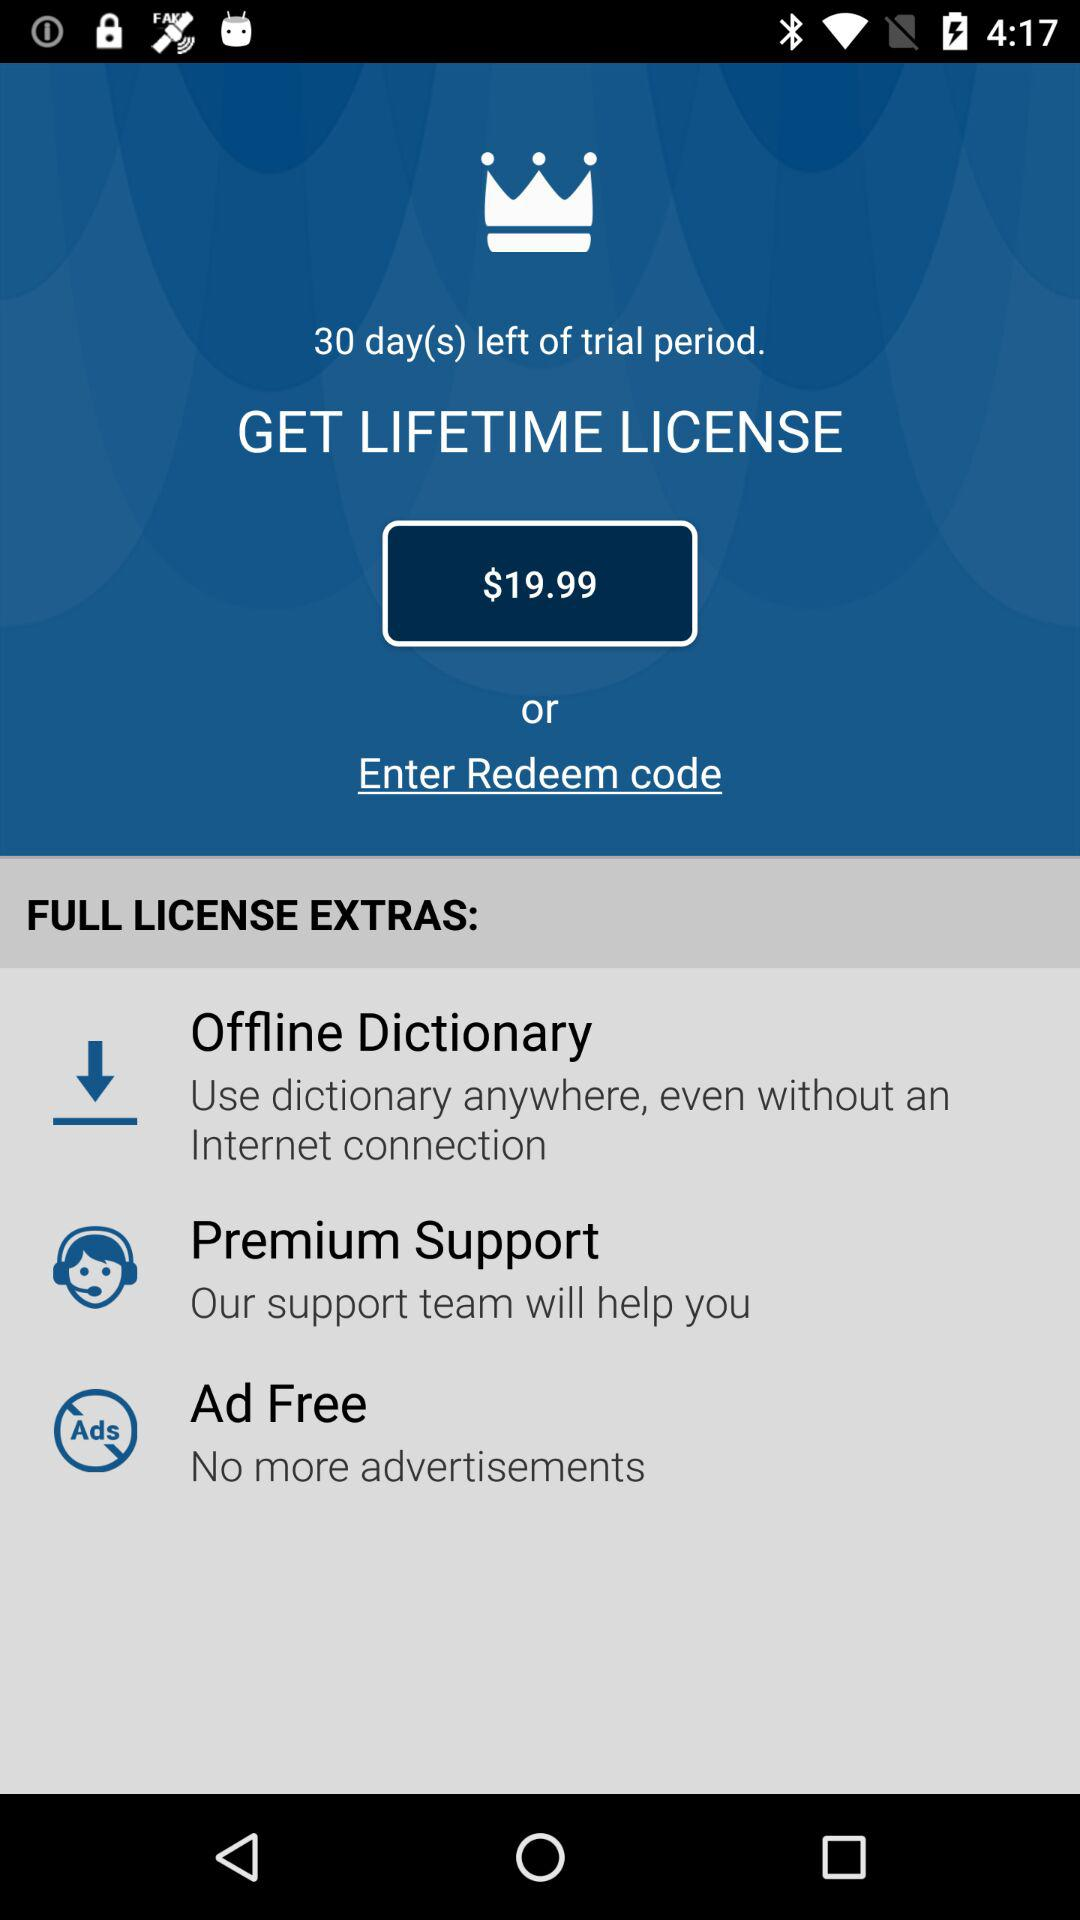How many dollars is the lifetime license?
Answer the question using a single word or phrase. $19.99 